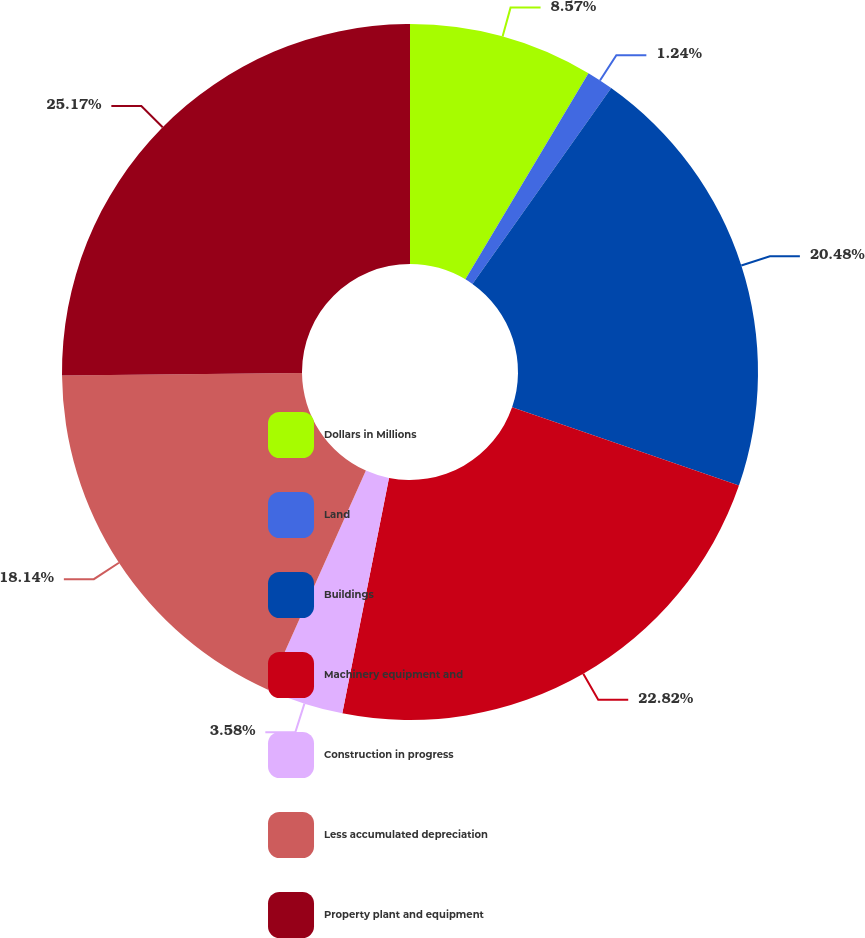Convert chart to OTSL. <chart><loc_0><loc_0><loc_500><loc_500><pie_chart><fcel>Dollars in Millions<fcel>Land<fcel>Buildings<fcel>Machinery equipment and<fcel>Construction in progress<fcel>Less accumulated depreciation<fcel>Property plant and equipment<nl><fcel>8.57%<fcel>1.24%<fcel>20.48%<fcel>22.82%<fcel>3.58%<fcel>18.14%<fcel>25.16%<nl></chart> 